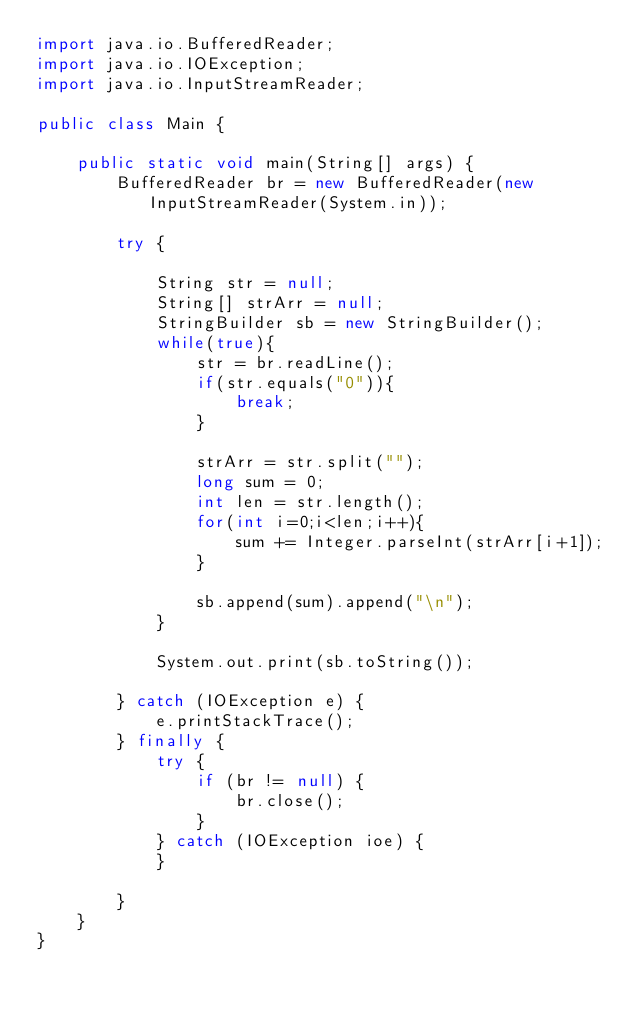Convert code to text. <code><loc_0><loc_0><loc_500><loc_500><_Java_>import java.io.BufferedReader;
import java.io.IOException;
import java.io.InputStreamReader;
 
public class Main {
 
    public static void main(String[] args) {
        BufferedReader br = new BufferedReader(new InputStreamReader(System.in));
 
        try {
 
            String str = null;
            String[] strArr = null;
            StringBuilder sb = new StringBuilder();
            while(true){
                str = br.readLine();
                if(str.equals("0")){
                    break;
                }
 
                strArr = str.split("");
                long sum = 0;
                int len = str.length();
                for(int i=0;i<len;i++){
                    sum += Integer.parseInt(strArr[i+1]);
                }
 
                sb.append(sum).append("\n");
            }
 
            System.out.print(sb.toString());
 
        } catch (IOException e) {
            e.printStackTrace();
        } finally {
            try {
                if (br != null) {
                    br.close();
                }
            } catch (IOException ioe) {
            }
 
        }
    }
}</code> 